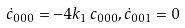<formula> <loc_0><loc_0><loc_500><loc_500>\dot { c } _ { 0 0 0 } = - 4 k _ { 1 } \, c _ { 0 0 0 } , \dot { c } _ { 0 0 1 } = 0</formula> 